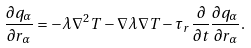<formula> <loc_0><loc_0><loc_500><loc_500>\frac { \partial q _ { \alpha } } { \partial { r _ { \alpha } } } = - \lambda \nabla ^ { 2 } T - \nabla \lambda \nabla T - \tau _ { r } \frac { \partial } { \partial t } \frac { \partial q _ { \alpha } } { \partial { r _ { \alpha } } } .</formula> 